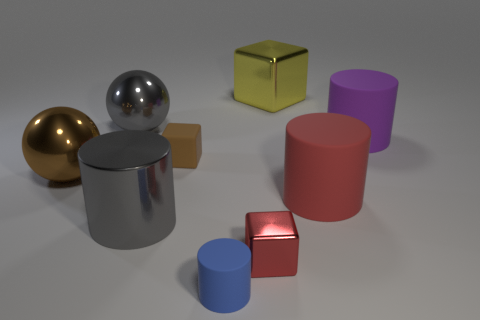Subtract 1 cylinders. How many cylinders are left? 3 Add 1 cyan metal things. How many objects exist? 10 Subtract all blocks. How many objects are left? 6 Add 7 large gray things. How many large gray things exist? 9 Subtract 1 gray cylinders. How many objects are left? 8 Subtract all tiny rubber things. Subtract all large gray cylinders. How many objects are left? 6 Add 8 big gray balls. How many big gray balls are left? 9 